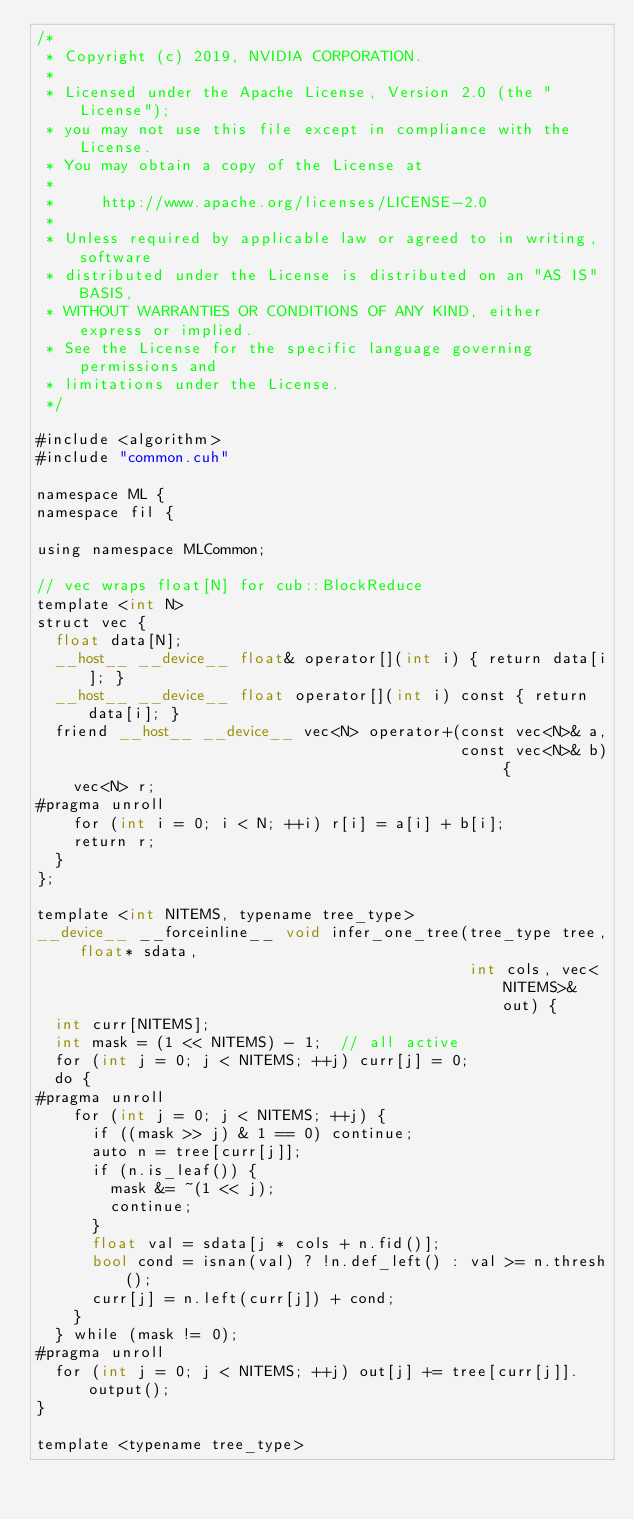<code> <loc_0><loc_0><loc_500><loc_500><_Cuda_>/*
 * Copyright (c) 2019, NVIDIA CORPORATION.
 *
 * Licensed under the Apache License, Version 2.0 (the "License");
 * you may not use this file except in compliance with the License.
 * You may obtain a copy of the License at
 *
 *     http://www.apache.org/licenses/LICENSE-2.0
 *
 * Unless required by applicable law or agreed to in writing, software
 * distributed under the License is distributed on an "AS IS" BASIS,
 * WITHOUT WARRANTIES OR CONDITIONS OF ANY KIND, either express or implied.
 * See the License for the specific language governing permissions and
 * limitations under the License.
 */

#include <algorithm>
#include "common.cuh"

namespace ML {
namespace fil {

using namespace MLCommon;

// vec wraps float[N] for cub::BlockReduce
template <int N>
struct vec {
  float data[N];
  __host__ __device__ float& operator[](int i) { return data[i]; }
  __host__ __device__ float operator[](int i) const { return data[i]; }
  friend __host__ __device__ vec<N> operator+(const vec<N>& a,
                                              const vec<N>& b) {
    vec<N> r;
#pragma unroll
    for (int i = 0; i < N; ++i) r[i] = a[i] + b[i];
    return r;
  }
};

template <int NITEMS, typename tree_type>
__device__ __forceinline__ void infer_one_tree(tree_type tree, float* sdata,
                                               int cols, vec<NITEMS>& out) {
  int curr[NITEMS];
  int mask = (1 << NITEMS) - 1;  // all active
  for (int j = 0; j < NITEMS; ++j) curr[j] = 0;
  do {
#pragma unroll
    for (int j = 0; j < NITEMS; ++j) {
      if ((mask >> j) & 1 == 0) continue;
      auto n = tree[curr[j]];
      if (n.is_leaf()) {
        mask &= ~(1 << j);
        continue;
      }
      float val = sdata[j * cols + n.fid()];
      bool cond = isnan(val) ? !n.def_left() : val >= n.thresh();
      curr[j] = n.left(curr[j]) + cond;
    }
  } while (mask != 0);
#pragma unroll
  for (int j = 0; j < NITEMS; ++j) out[j] += tree[curr[j]].output();
}

template <typename tree_type></code> 